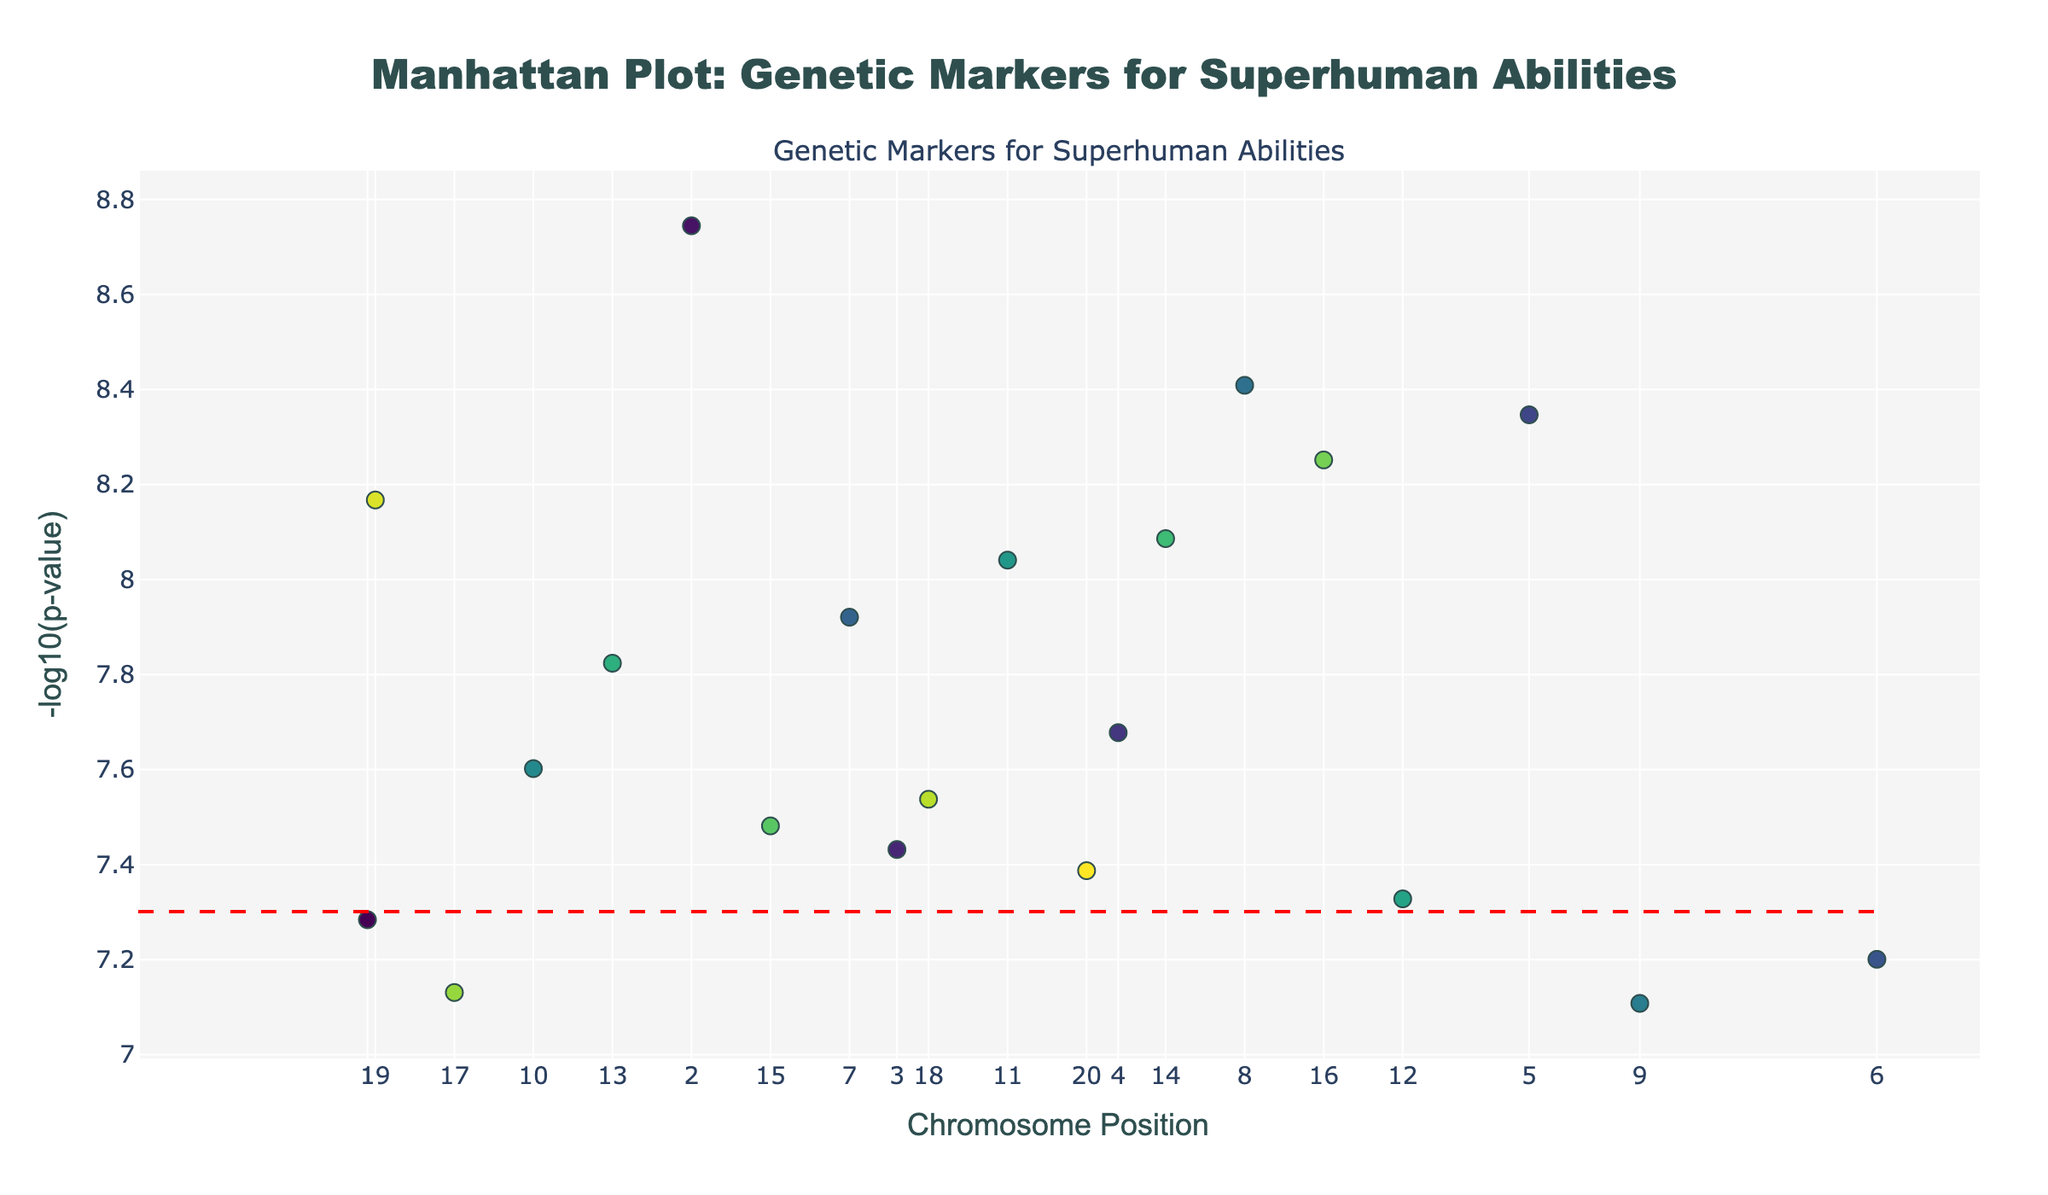What is the title of the plot? The title is prominently displayed at the top of the figure. It provides a summary of what the plot represents. In this case, it states, "Manhattan Plot: Genetic Markers for Superhuman Abilities".
Answer: Manhattan Plot: Genetic Markers for Superhuman Abilities What does the y-axis represent in the plot? The y-axis is labeled and shows the "-log10(p-value)", which indicates the statistical significance of genetic markers. Higher values correspond to lower p-values and greater significance.
Answer: -log10(p-value) Which chromosome has the genetic marker with the most significant p-value? By examining the plot, the chromosome with the highest -log10(p-value) is determined. Based on the hover text in the figure, Chromosome 2 has the lowest p-value (1.8e-9), making its marker the most significant.
Answer: Chromosome 2 How is the significance threshold visually marked in the plot? The significance threshold is marked by a horizontal dashed red line across the plot. By carefully observing, you can see this line and its purpose to demarcate significant value.
Answer: A horizontal dashed red line Which gene corresponds to the highest -log10(p-value) on Chromosome 7 and what ability is it associated with? By observing the data points corresponding to Chromosome 7 and analyzing the hover text for the highest -log10(p-value), we determine that PPARG is the gene, and it is associated with Enhanced Metabolism.
Answer: PPARG, Enhanced Metabolism What pattern of colors is used to distinguish different chromosomes? Observing the figure, different chromosomes are colored using a colorscale ranging from light to dark shades (Viridis). This visually differentiates chromosomes.
Answer: A colorscale from light to dark shades (Viridis) Compare the genetic markers for IGF2 and COMT: which one is more statistically significant? By examining their respective -log10(p-values) in the plot, IGF2 (8.2e-9) has a higher -log10(p-value) than COMT (7.8e-8), making IGF2 more statistically significant.
Answer: IGF2 What does a high -log10(p-value) indicate about a genetic marker's significance? Higher -log10(p-values) indicate lower p-values, meaning the genetic marker is more statistically significant, reflecting a stronger association.
Answer: Greater statistical significance How many genetic markers have a -log10(p-value) higher than the significance line? By counting the data points above the horizontal dashed red line in the plot, we determine how many genetic markers surpass the significance threshold.
Answer: 20 